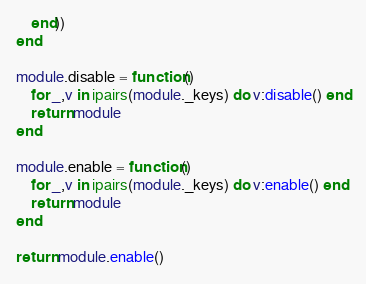<code> <loc_0><loc_0><loc_500><loc_500><_Lua_>    end))
end

module.disable = function()
    for _,v in ipairs(module._keys) do v:disable() end
    return module
end

module.enable = function()
    for _,v in ipairs(module._keys) do v:enable() end
    return module
end

return module.enable()
</code> 